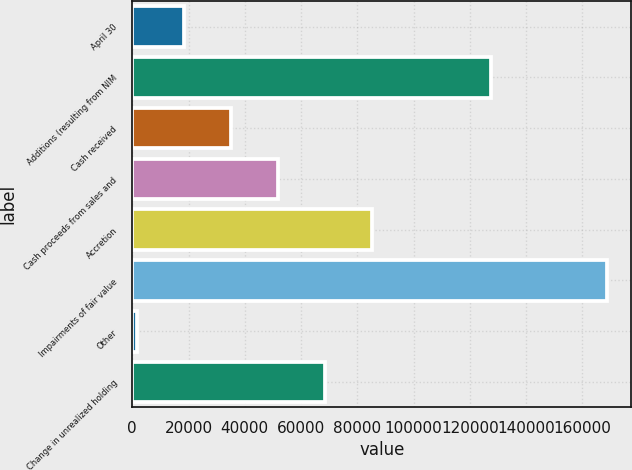<chart> <loc_0><loc_0><loc_500><loc_500><bar_chart><fcel>April 30<fcel>Additions (resulting from NIM<fcel>Cash received<fcel>Cash proceeds from sales and<fcel>Accretion<fcel>Impairments of fair value<fcel>Other<fcel>Change in unrealized holding<nl><fcel>18392.6<fcel>127580<fcel>35113.2<fcel>51833.8<fcel>85275<fcel>168878<fcel>1672<fcel>68554.4<nl></chart> 